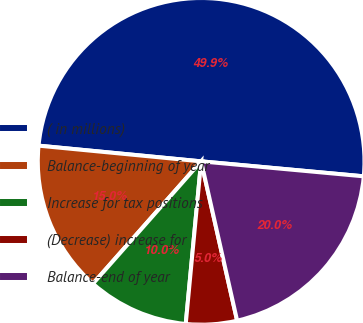<chart> <loc_0><loc_0><loc_500><loc_500><pie_chart><fcel>( in millions)<fcel>Balance-beginning of year<fcel>Increase for tax positions<fcel>(Decrease) increase for<fcel>Balance-end of year<nl><fcel>49.93%<fcel>15.01%<fcel>10.02%<fcel>5.04%<fcel>20.0%<nl></chart> 